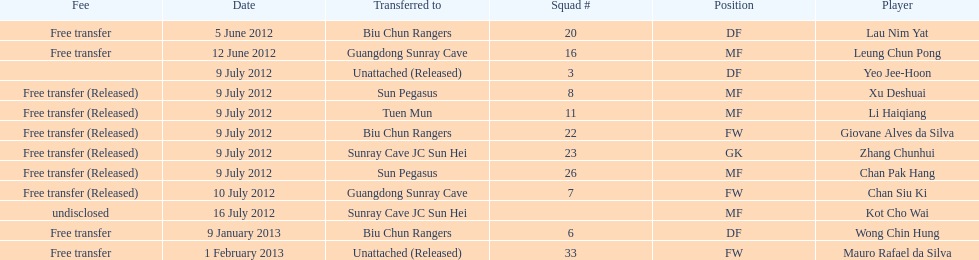Li haiqiang and xu deshuai both played which position? MF. 